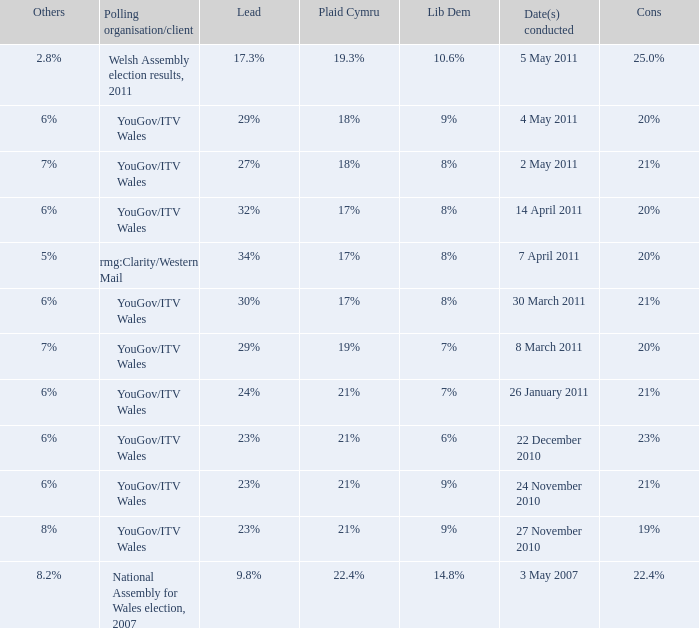I want the plaid cymru for Polling organisation/client of yougov/itv wales for 4 may 2011 18%. 